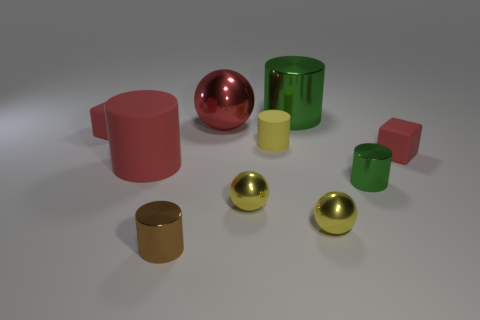Is the large sphere the same color as the big rubber object?
Your response must be concise. Yes. How many other objects are the same material as the red cylinder?
Give a very brief answer. 3. There is a green metal thing in front of the small red rubber cube on the left side of the brown shiny object; what shape is it?
Keep it short and to the point. Cylinder. There is a red sphere left of the big metal cylinder; what is its size?
Keep it short and to the point. Large. Is the material of the brown cylinder the same as the small green thing?
Your answer should be very brief. Yes. What shape is the brown object that is the same material as the small green thing?
Provide a succinct answer. Cylinder. There is a small cylinder that is left of the red metal thing; what color is it?
Keep it short and to the point. Brown. There is a big thing in front of the big red metallic ball; does it have the same color as the large metallic sphere?
Ensure brevity in your answer.  Yes. There is a yellow thing that is the same shape as the brown thing; what material is it?
Your answer should be very brief. Rubber. What number of brown things are the same size as the brown cylinder?
Keep it short and to the point. 0. 